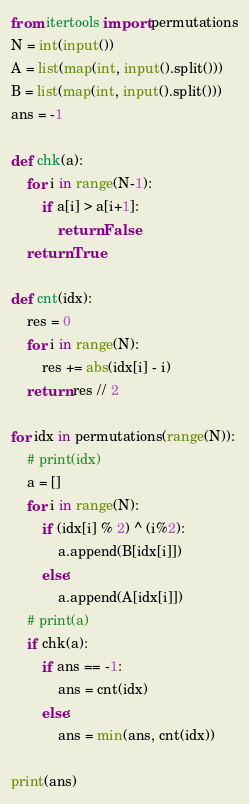Convert code to text. <code><loc_0><loc_0><loc_500><loc_500><_Python_>from itertools import permutations
N = int(input())
A = list(map(int, input().split()))
B = list(map(int, input().split()))
ans = -1

def chk(a):
    for i in range(N-1):
        if a[i] > a[i+1]:
            return False
    return True

def cnt(idx):
    res = 0
    for i in range(N):
        res += abs(idx[i] - i)
    return res // 2

for idx in permutations(range(N)):
    # print(idx)
    a = []
    for i in range(N):
        if (idx[i] % 2) ^ (i%2):
            a.append(B[idx[i]])
        else:
            a.append(A[idx[i]])
    # print(a)
    if chk(a):
        if ans == -1:
            ans = cnt(idx)
        else:
            ans = min(ans, cnt(idx))

print(ans)
</code> 